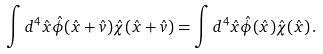<formula> <loc_0><loc_0><loc_500><loc_500>\int d ^ { 4 } { \hat { x } } { \hat { \phi } } ( { \hat { x } } + { \hat { v } } ) { \hat { \chi } } ( { \hat { x } } + { \hat { v } } ) = \int d ^ { 4 } { \hat { x } } { \hat { \phi } } ( { \hat { x } } ) { \hat { \chi } } ( { \hat { x } } ) \, .</formula> 